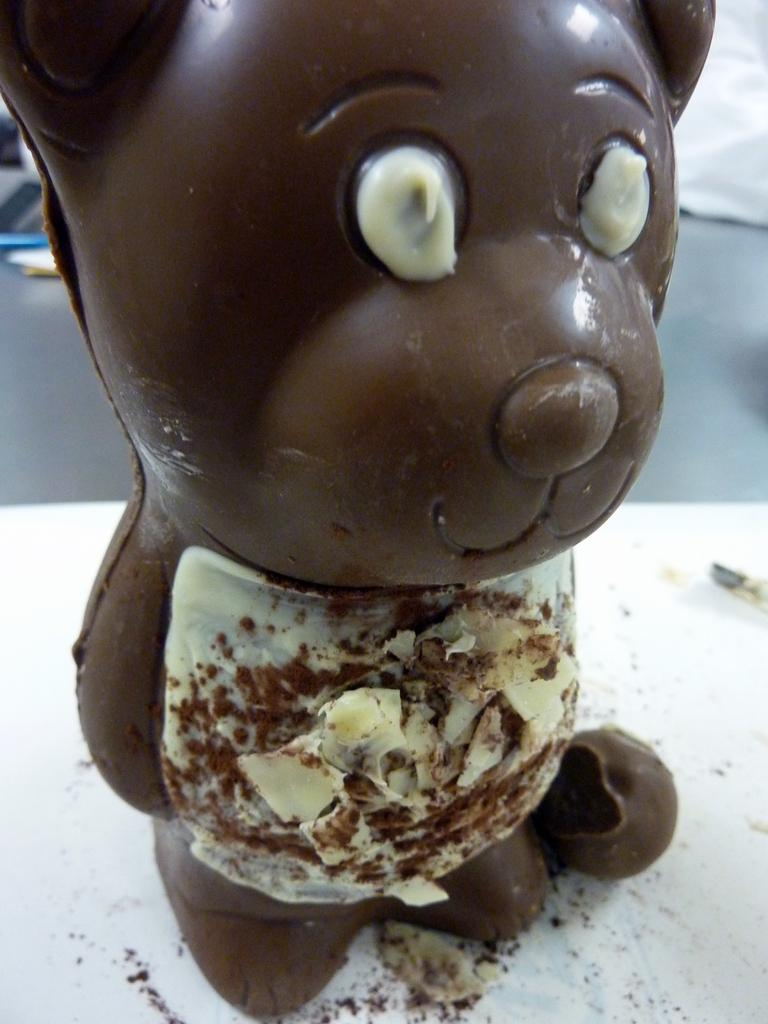What type of object is depicted in the image? The object is a chocolate teddy bear. Can you describe the appearance of the chocolate teddy bear? The chocolate teddy bear has a teddy bear shape and is made of chocolate. What type of flowers are surrounding the chocolate teddy bear in the image? There are no flowers present in the image; it only features a chocolate teddy bear. Can you describe the snowy landscape in the image? There is no snow or landscape present in the image; it only features a chocolate teddy bear. 